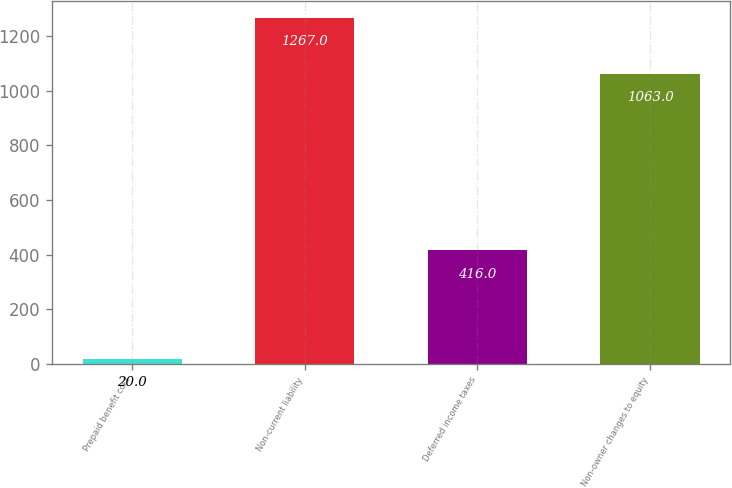Convert chart to OTSL. <chart><loc_0><loc_0><loc_500><loc_500><bar_chart><fcel>Prepaid benefit cost<fcel>Non-current liability<fcel>Deferred income taxes<fcel>Non-owner changes to equity<nl><fcel>20<fcel>1267<fcel>416<fcel>1063<nl></chart> 